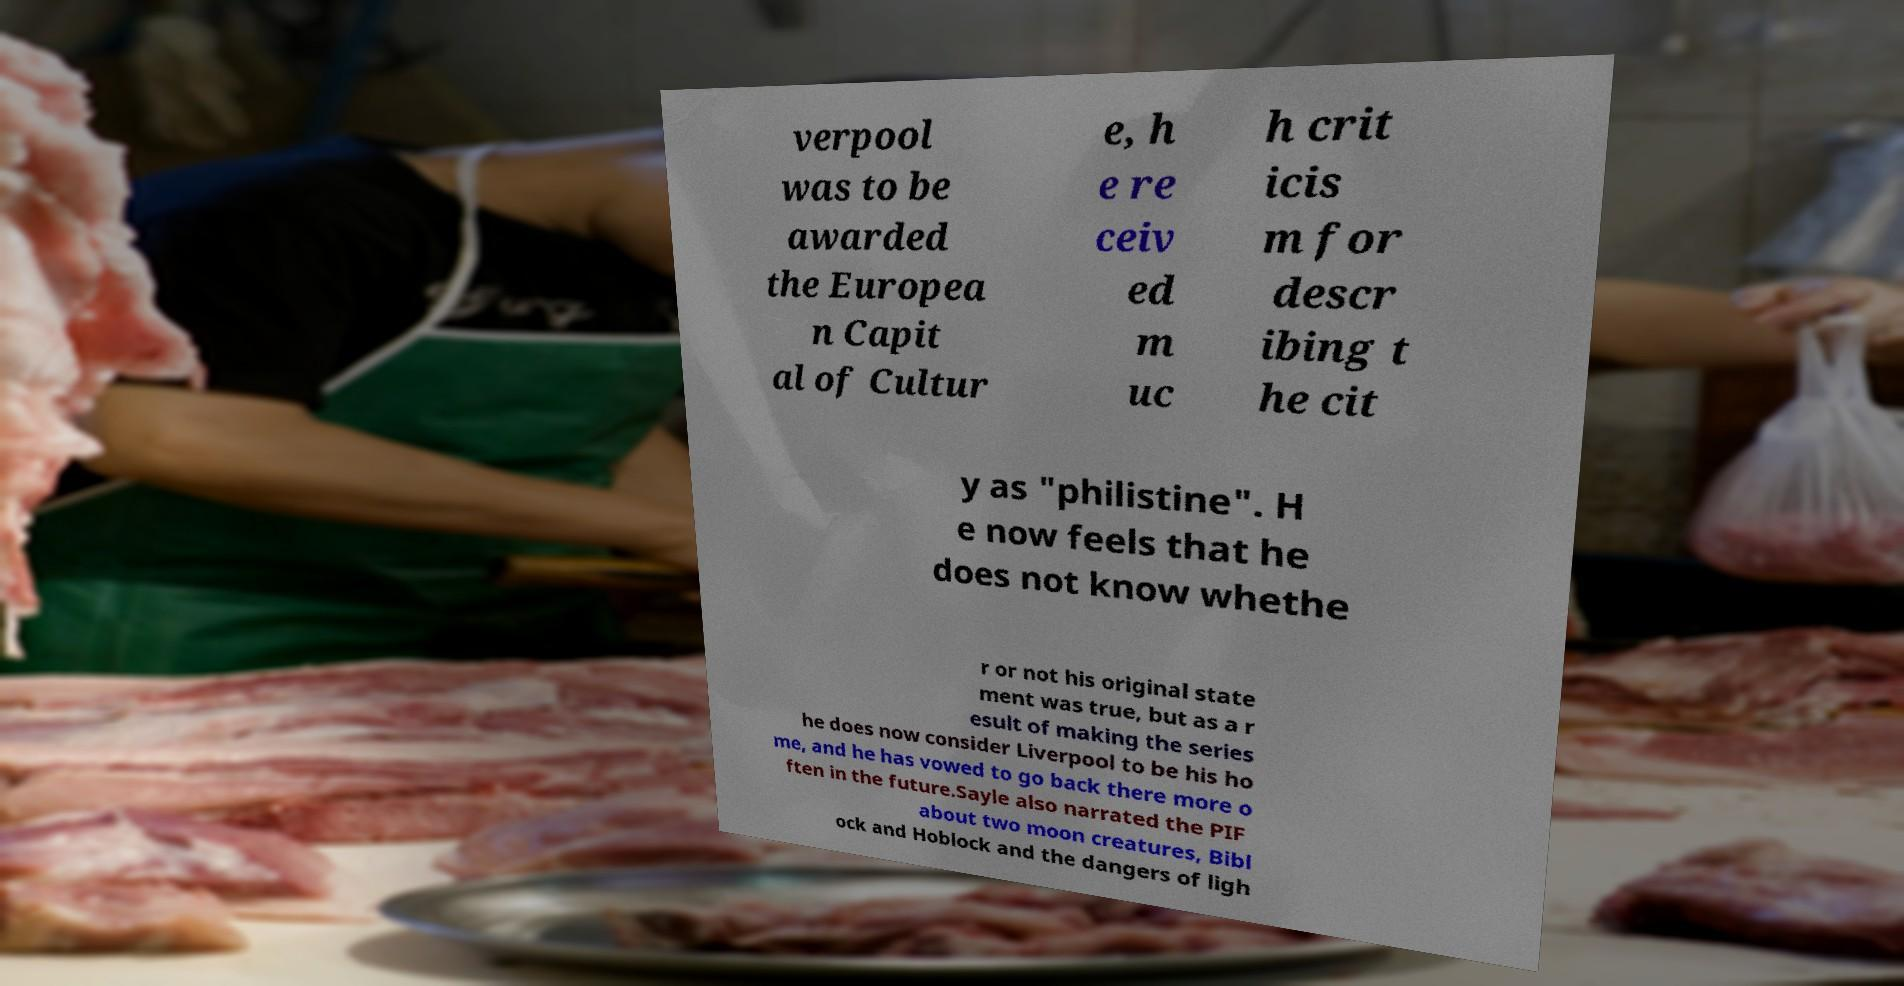For documentation purposes, I need the text within this image transcribed. Could you provide that? verpool was to be awarded the Europea n Capit al of Cultur e, h e re ceiv ed m uc h crit icis m for descr ibing t he cit y as "philistine". H e now feels that he does not know whethe r or not his original state ment was true, but as a r esult of making the series he does now consider Liverpool to be his ho me, and he has vowed to go back there more o ften in the future.Sayle also narrated the PIF about two moon creatures, Bibl ock and Hoblock and the dangers of ligh 